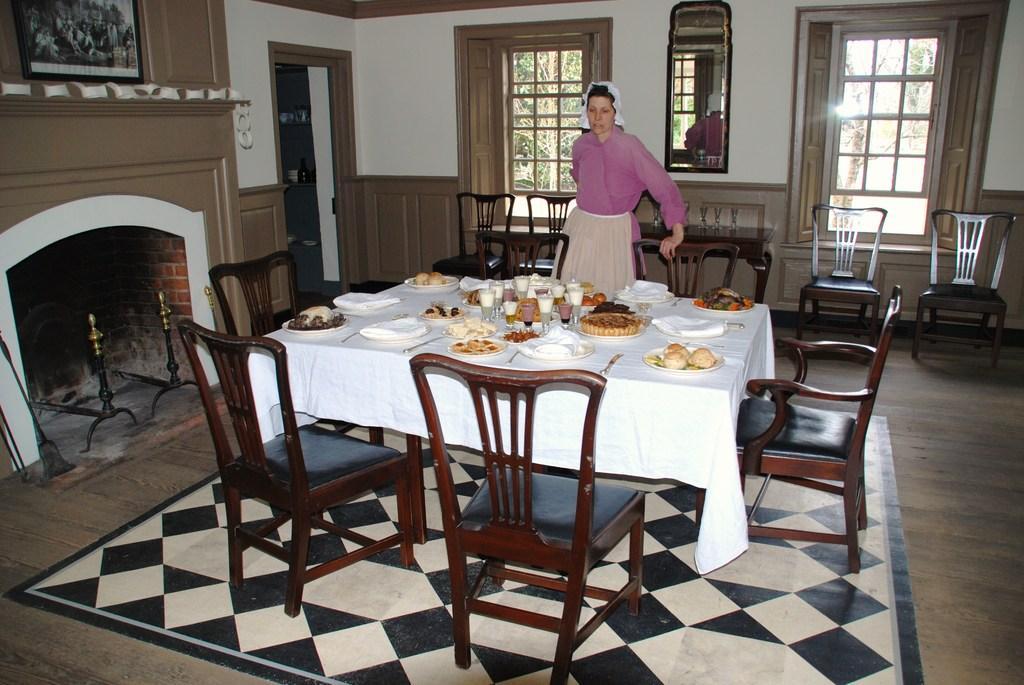In one or two sentences, can you explain what this image depicts? As we can see in the image there is a white color wall, windows, mirror, a woman standing over here and there are chairs and tables. On table there is a white color cloth, plate, tissues, glasses, cake and food items. 